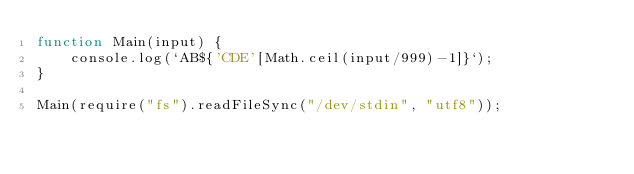Convert code to text. <code><loc_0><loc_0><loc_500><loc_500><_JavaScript_>function Main(input) {
	console.log(`AB${'CDE'[Math.ceil(input/999)-1]}`);
}

Main(require("fs").readFileSync("/dev/stdin", "utf8"));</code> 